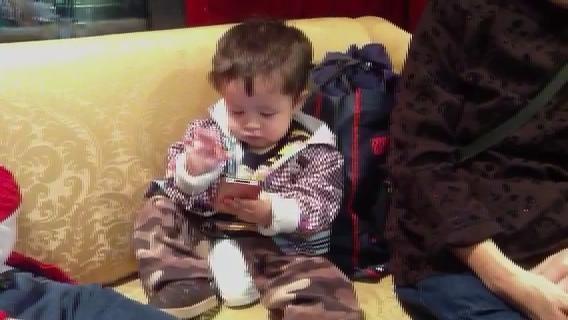What holiday is likely being celebrated here?
Indicate the correct response by choosing from the four available options to answer the question.
Options: Christmas, april fools, columbus day, indigenous people's. Christmas. 